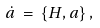<formula> <loc_0><loc_0><loc_500><loc_500>\dot { a } \, = \, \{ H , a \} \, ,</formula> 